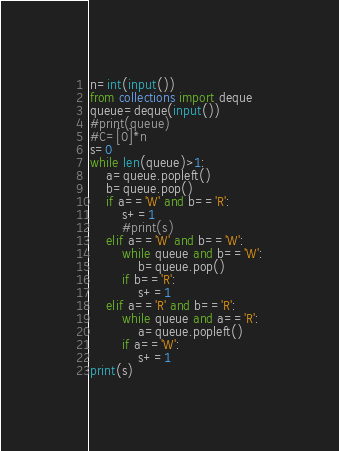Convert code to text. <code><loc_0><loc_0><loc_500><loc_500><_Python_>n=int(input())
from collections import deque
queue=deque(input())
#print(queue)
#C=[0]*n
s=0
while len(queue)>1:
    a=queue.popleft()
    b=queue.pop()
    if a=='W' and b=='R':
        s+=1
        #print(s)
    elif a=='W' and b=='W':
        while queue and b=='W':
            b=queue.pop()
        if b=='R':
            s+=1
    elif a=='R' and b=='R':
        while queue and a=='R':
            a=queue.popleft()
        if a=='W':
            s+=1                
print(s)</code> 